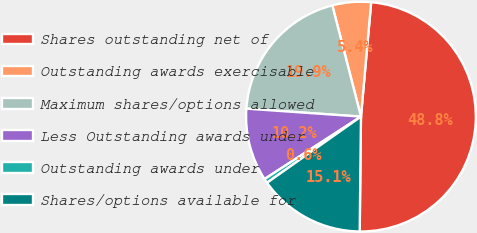Convert chart to OTSL. <chart><loc_0><loc_0><loc_500><loc_500><pie_chart><fcel>Shares outstanding net of<fcel>Outstanding awards exercisable<fcel>Maximum shares/options allowed<fcel>Less Outstanding awards under<fcel>Outstanding awards under<fcel>Shares/options available for<nl><fcel>48.76%<fcel>5.43%<fcel>19.88%<fcel>10.25%<fcel>0.62%<fcel>15.06%<nl></chart> 